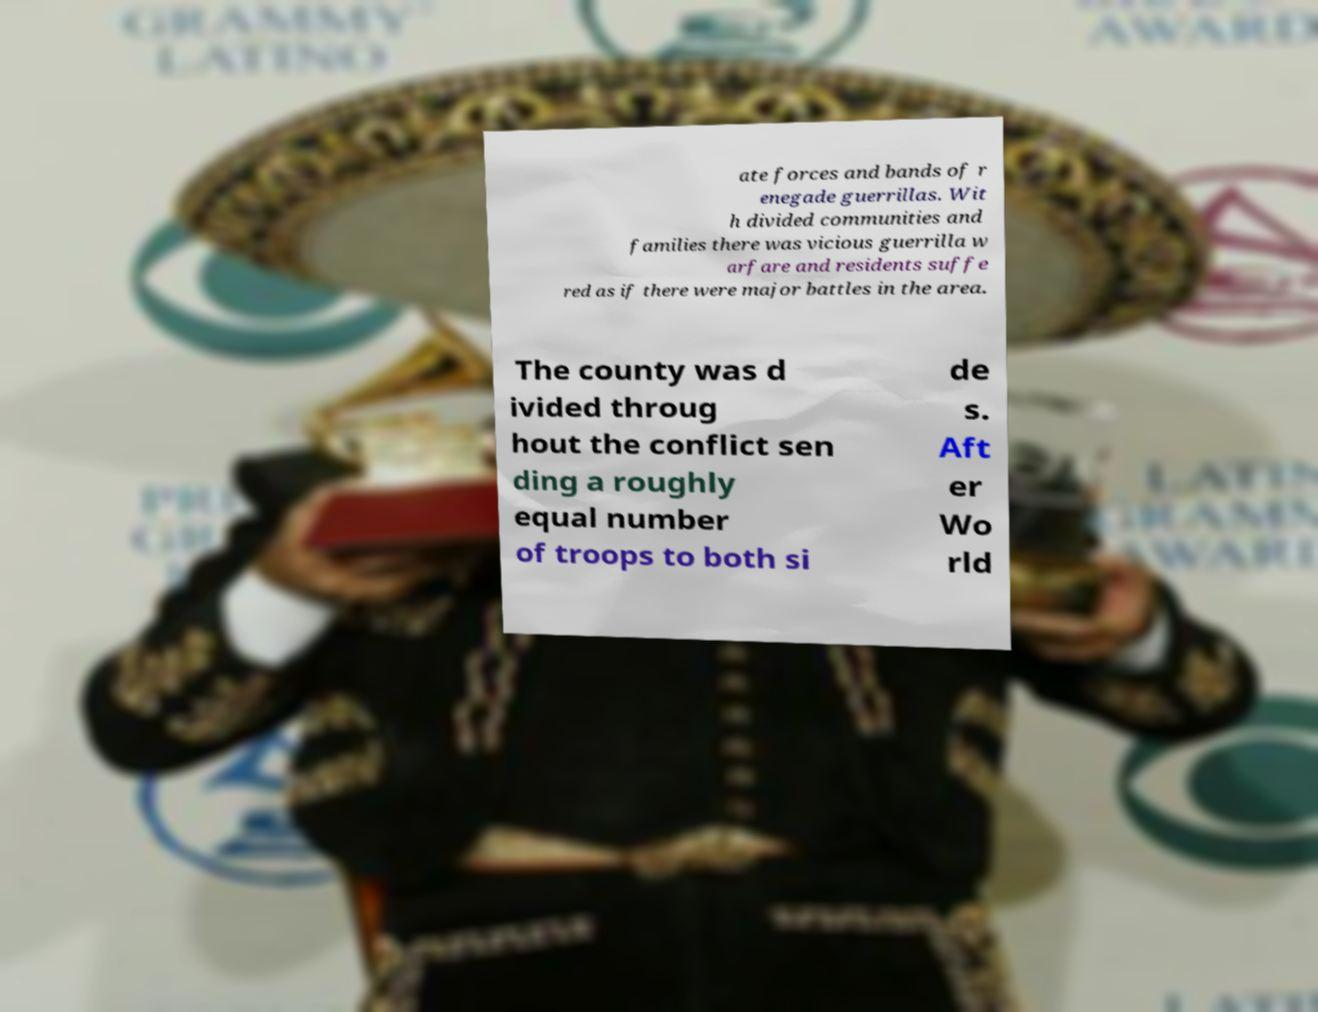Can you read and provide the text displayed in the image?This photo seems to have some interesting text. Can you extract and type it out for me? ate forces and bands of r enegade guerrillas. Wit h divided communities and families there was vicious guerrilla w arfare and residents suffe red as if there were major battles in the area. The county was d ivided throug hout the conflict sen ding a roughly equal number of troops to both si de s. Aft er Wo rld 